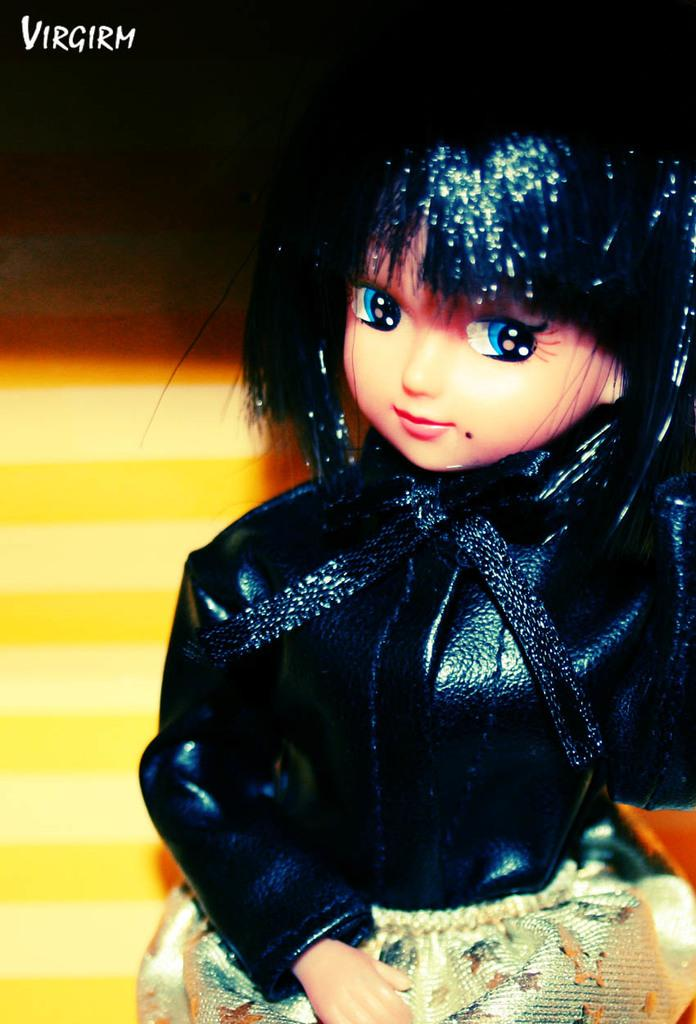What is the main subject of the image? There is a doll in the image. What is the doll wearing? The doll is wearing a black dress. How would you describe the overall color scheme of the image? The image has a dark background. Can you identify any additional features in the image? There is a watermark in the image. What type of watch is the doll wearing in the image? The doll is not wearing a watch in the image; it is wearing a black dress. Can you describe the machine that the doll is operating in the image? There is no machine present in the image; it features a doll wearing a black dress against a dark background. 